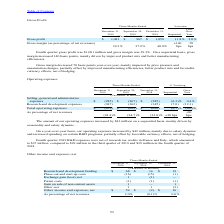According to Stmicroelectronics's financial document, Which program is associated to R&D? Based on the financial document, the answer is IPCEI program. Also, How much was the Other income and expenses, net in the fourth quarter of 2019? Based on the financial document, the answer is $54 million. Also, What led to increase in the other income and expenses, net in the fourth quarter of 2019? Based on the financial document, the answer is higher R&D grants in Italy associated with the IPCEI program.. Also, can you calculate: What is the average Research and development funding for the period December 31, 2019 and 2018? To answer this question, I need to perform calculations using the financial data. The calculation is: (68+19) / 2, which equals 43.5 (in millions). This is based on the information: "2019 September 29, Research and development funding $ 68 $ 14 $ 19..." The key data points involved are: 19, 68. Also, can you calculate: What is the average Other income and expenses, net for the period December 31, 2019 and 2018? To answer this question, I need to perform calculations using the financial data. The calculation is: (54+16) /2, which equals 35 (in millions). This is based on the information: "Other income and expenses, net $ 54 $ (2) $ 16 Phase-out and start-up costs (16) (15) (1)..." The key data points involved are: 16, 54. Also, can you calculate: What is the increase/ (decrease) in Research and development funding from the period December 31, 2018 to 2019? Based on the calculation: 68-19, the result is 49 (in millions). This is based on the information: "2019 September 29, Research and development funding $ 68 $ 14 $ 19..." The key data points involved are: 19, 68. 